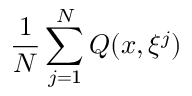Convert formula to latex. <formula><loc_0><loc_0><loc_500><loc_500>{ \frac { 1 } { N } } \sum _ { j = 1 } ^ { N } Q ( x , \xi ^ { j } )</formula> 